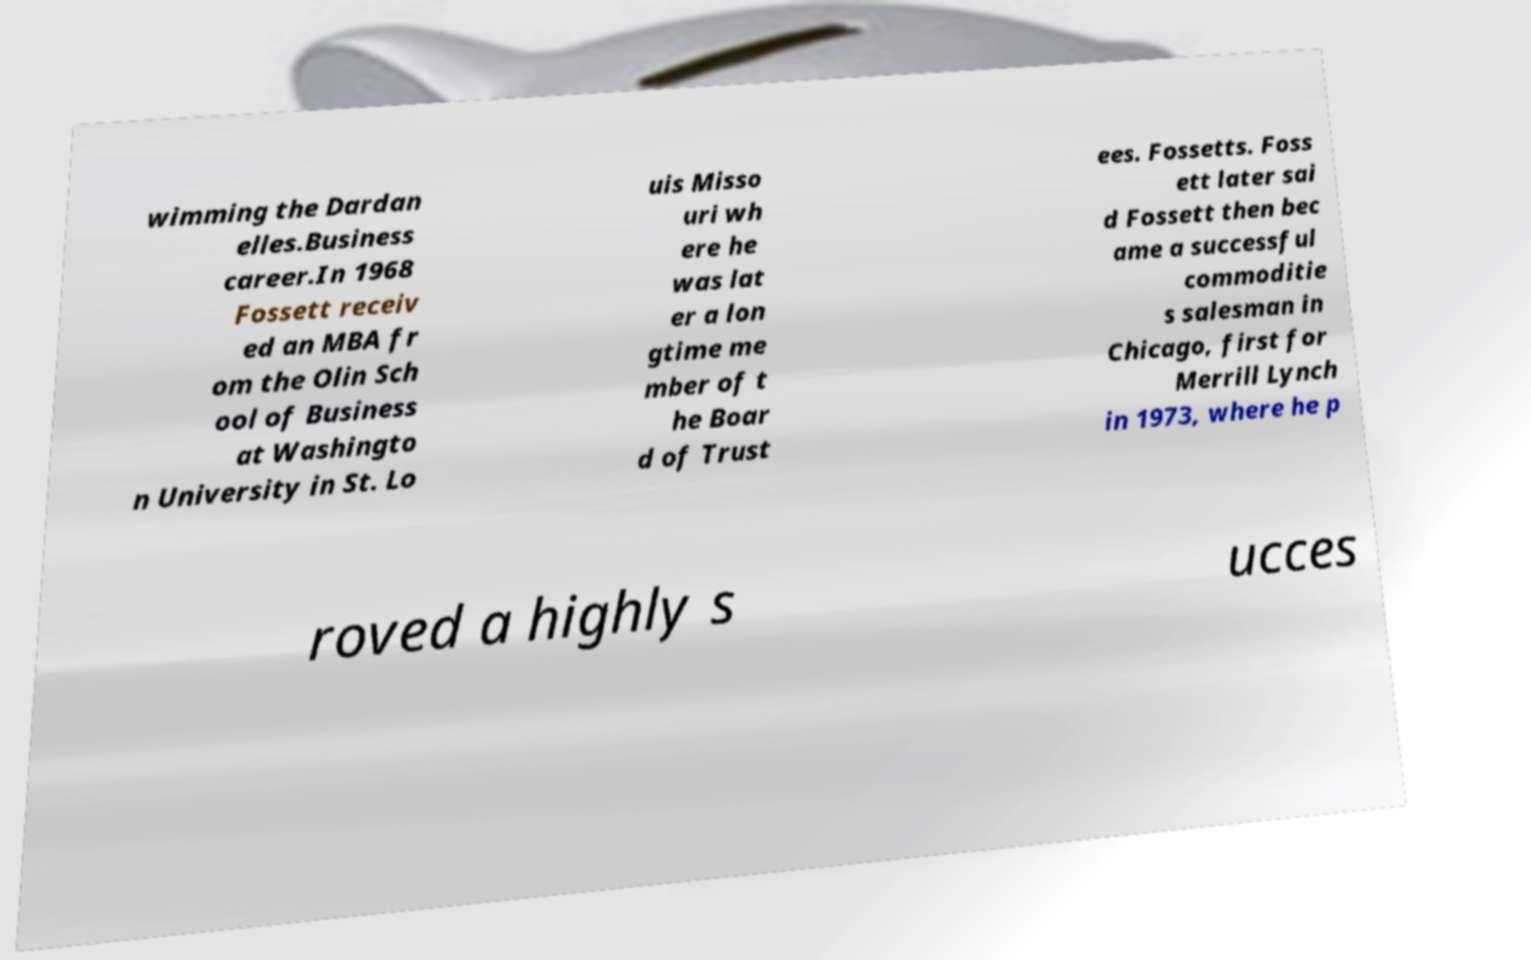Could you assist in decoding the text presented in this image and type it out clearly? wimming the Dardan elles.Business career.In 1968 Fossett receiv ed an MBA fr om the Olin Sch ool of Business at Washingto n University in St. Lo uis Misso uri wh ere he was lat er a lon gtime me mber of t he Boar d of Trust ees. Fossetts. Foss ett later sai d Fossett then bec ame a successful commoditie s salesman in Chicago, first for Merrill Lynch in 1973, where he p roved a highly s ucces 